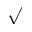Convert formula to latex. <formula><loc_0><loc_0><loc_500><loc_500>\surd</formula> 